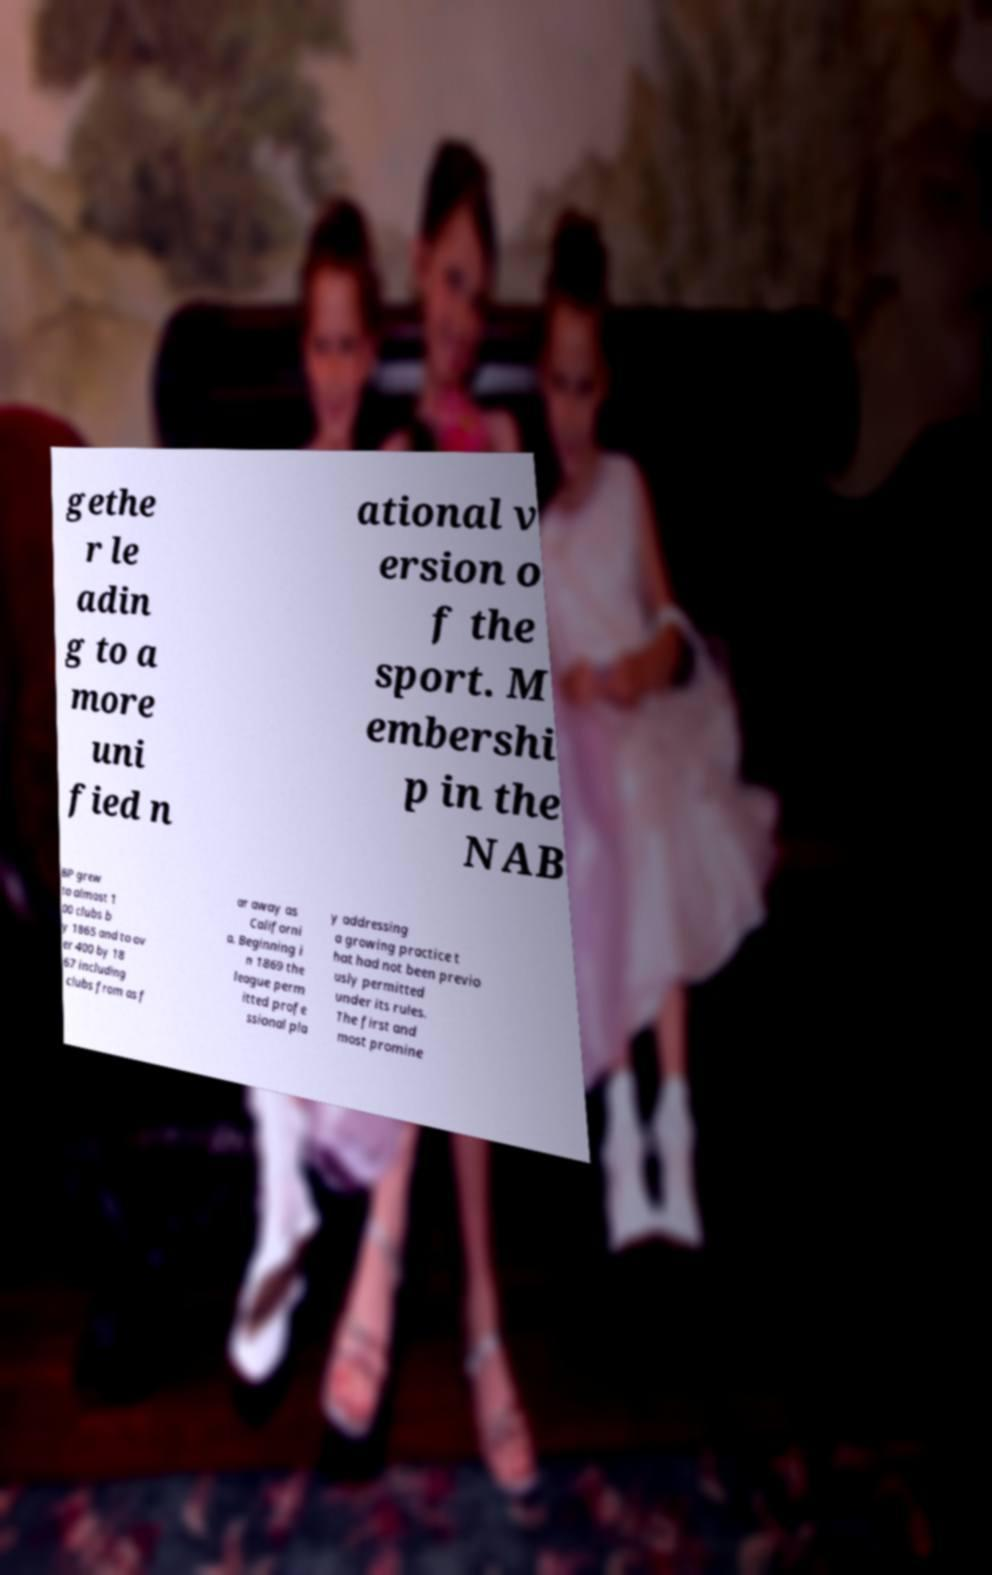What messages or text are displayed in this image? I need them in a readable, typed format. gethe r le adin g to a more uni fied n ational v ersion o f the sport. M embershi p in the NAB BP grew to almost 1 00 clubs b y 1865 and to ov er 400 by 18 67 including clubs from as f ar away as Californi a. Beginning i n 1869 the league perm itted profe ssional pla y addressing a growing practice t hat had not been previo usly permitted under its rules. The first and most promine 